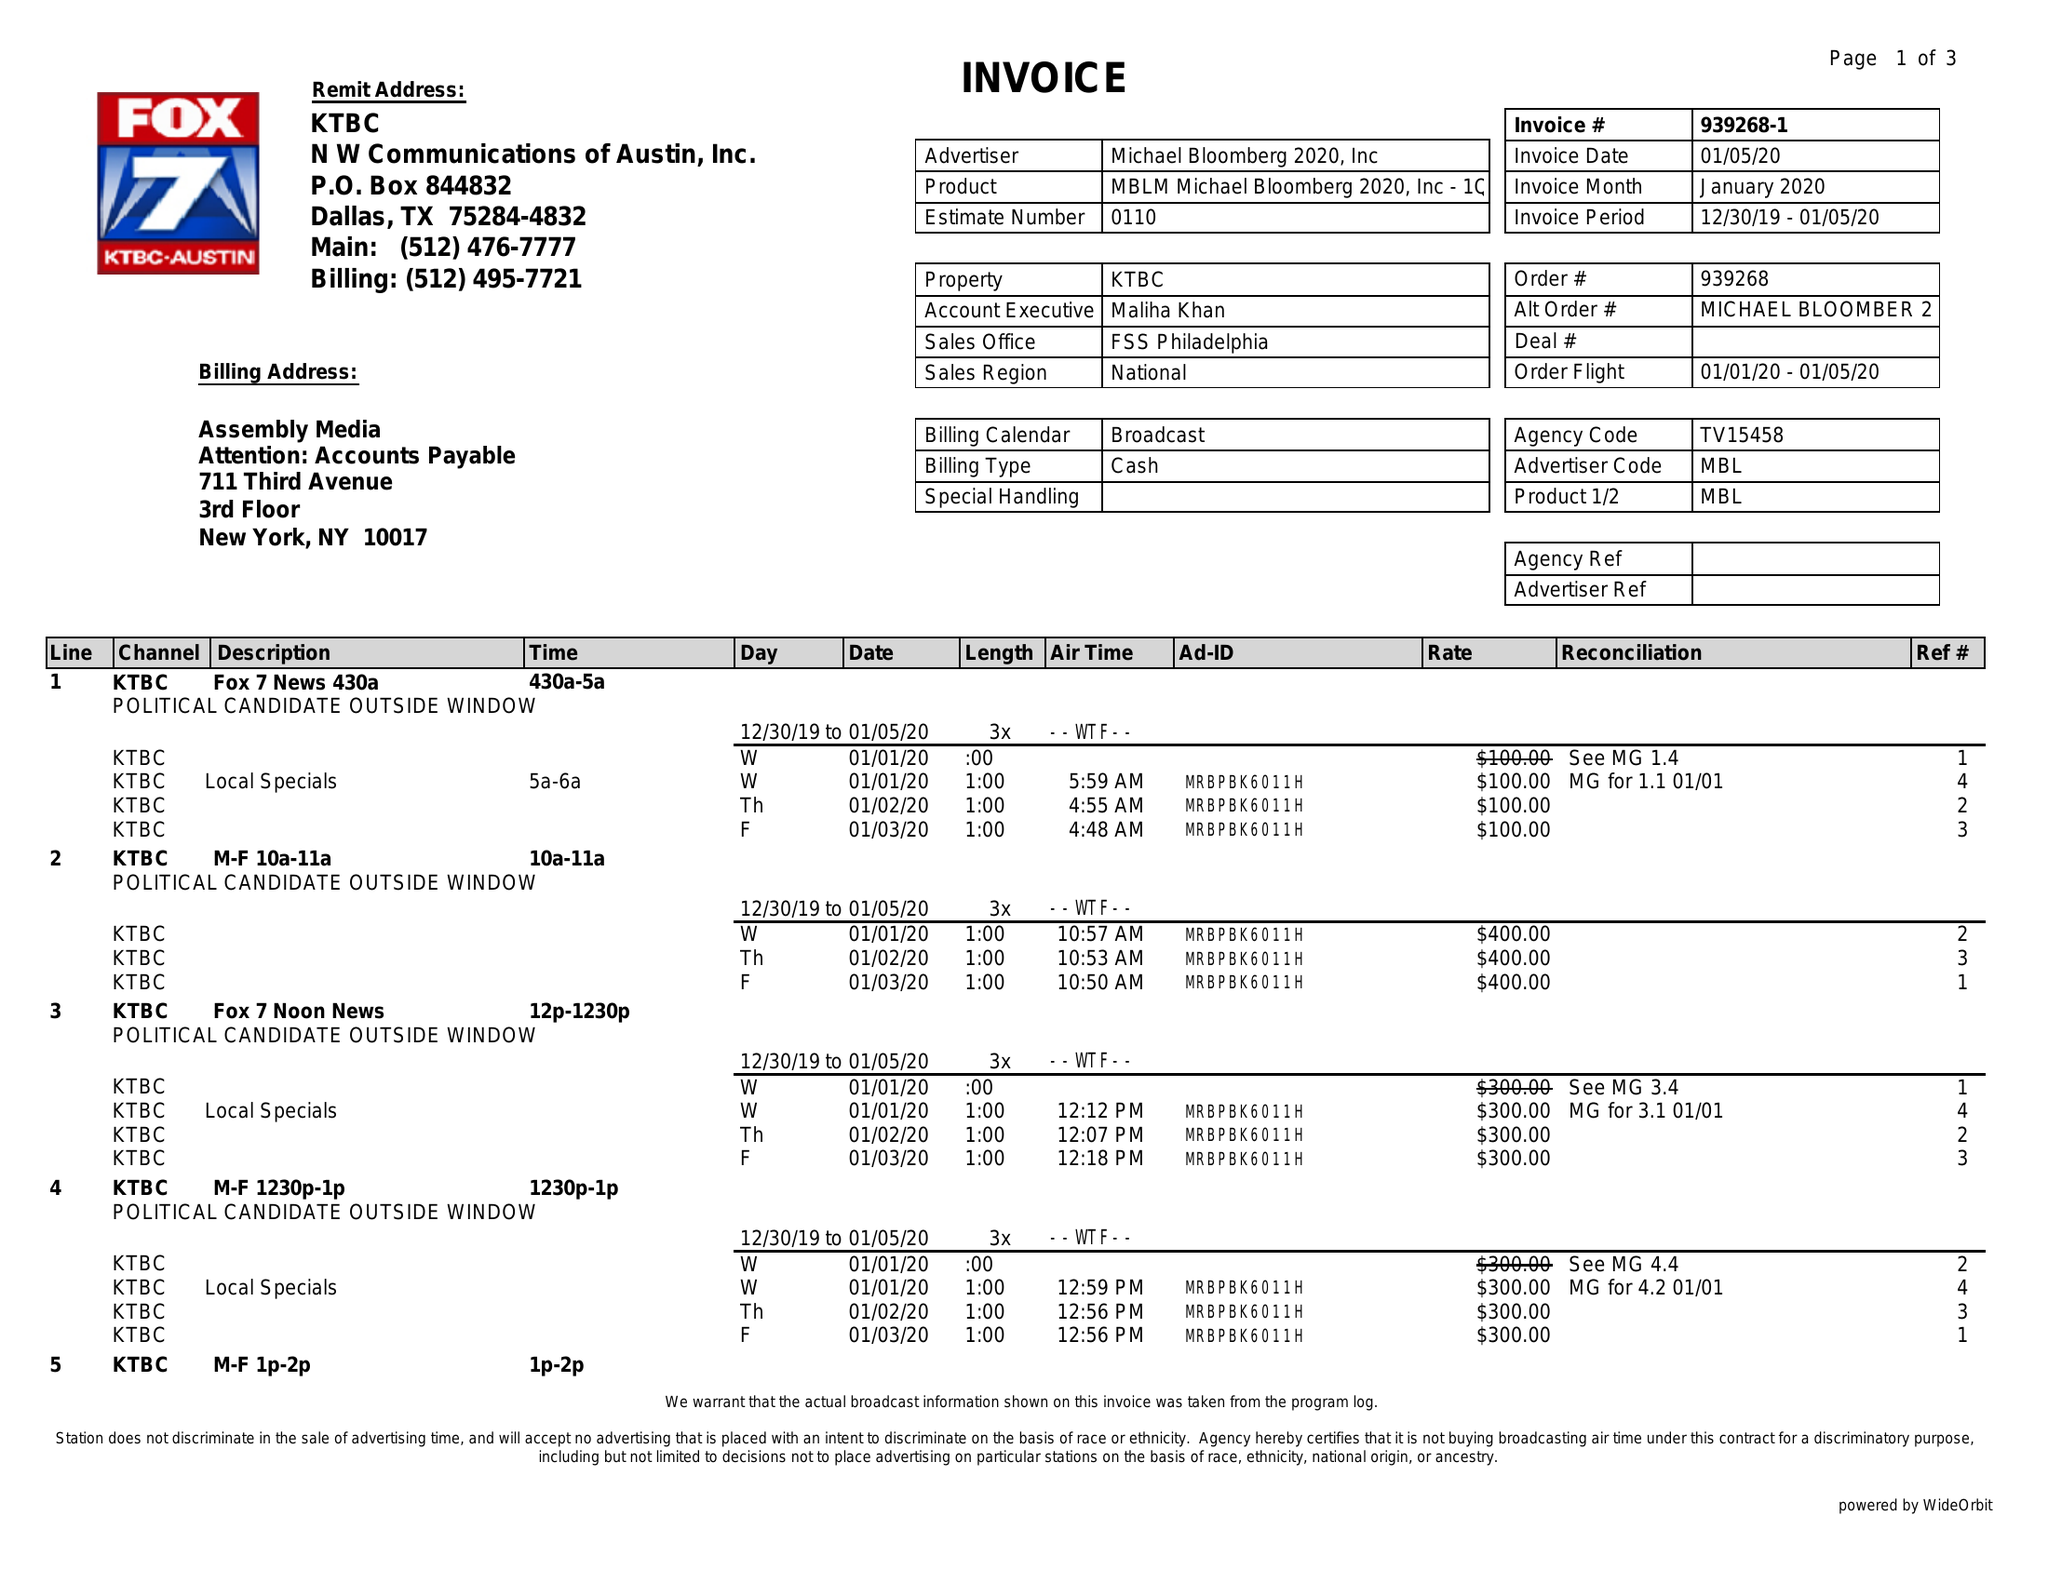What is the value for the gross_amount?
Answer the question using a single word or phrase. 15000.00 